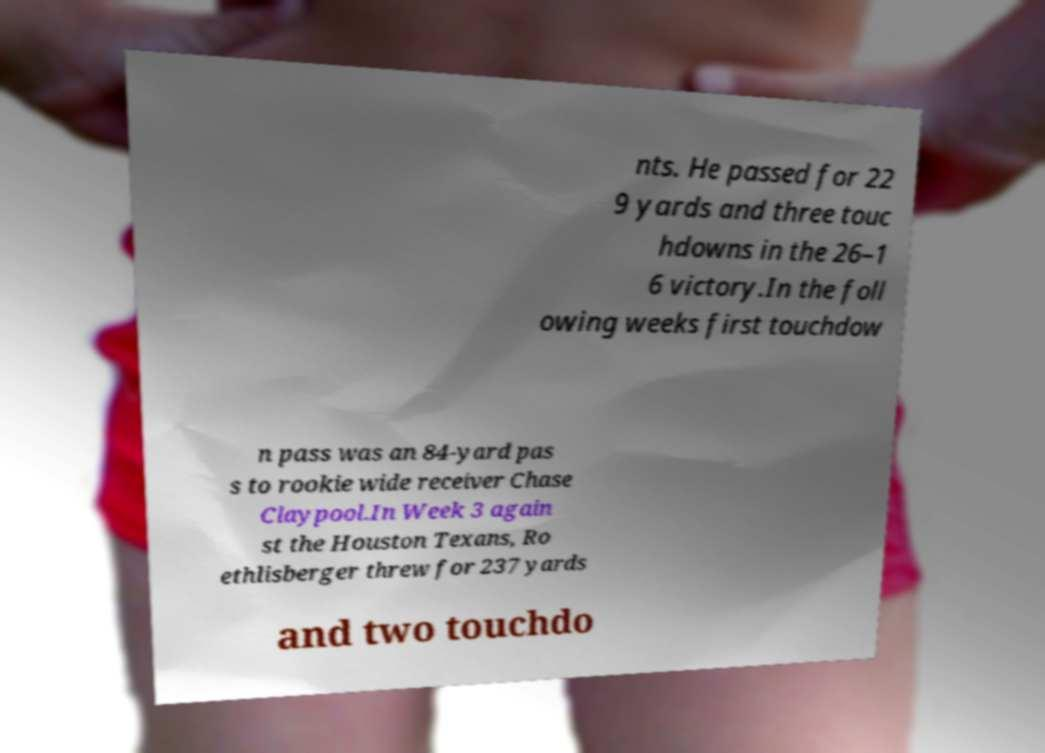There's text embedded in this image that I need extracted. Can you transcribe it verbatim? nts. He passed for 22 9 yards and three touc hdowns in the 26–1 6 victory.In the foll owing weeks first touchdow n pass was an 84-yard pas s to rookie wide receiver Chase Claypool.In Week 3 again st the Houston Texans, Ro ethlisberger threw for 237 yards and two touchdo 